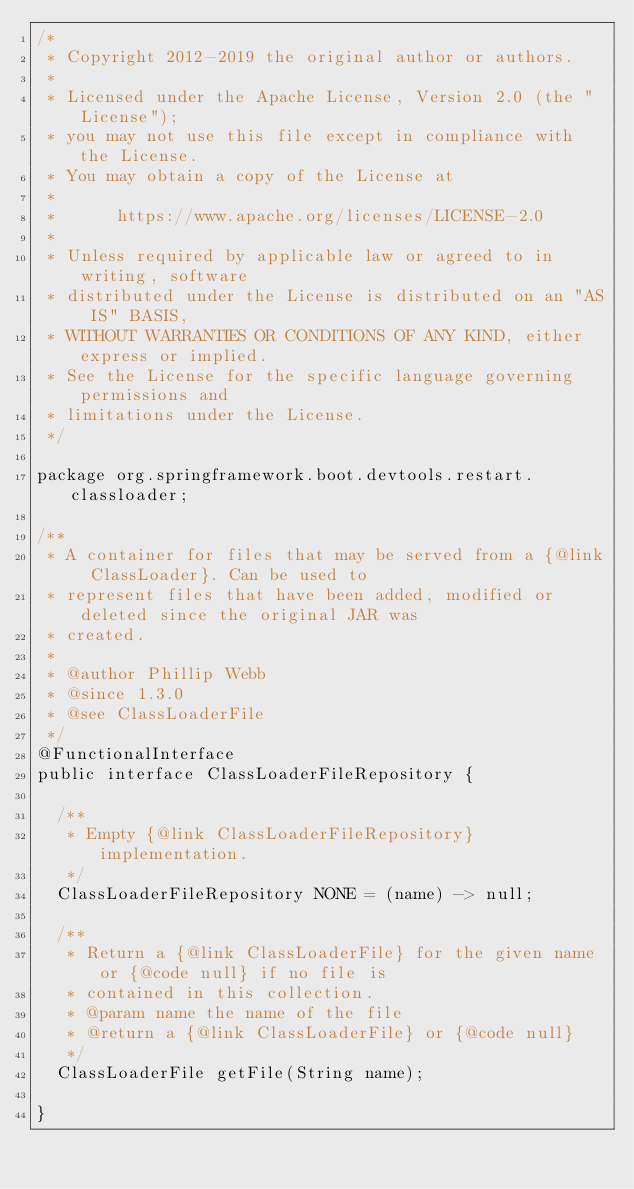Convert code to text. <code><loc_0><loc_0><loc_500><loc_500><_Java_>/*
 * Copyright 2012-2019 the original author or authors.
 *
 * Licensed under the Apache License, Version 2.0 (the "License");
 * you may not use this file except in compliance with the License.
 * You may obtain a copy of the License at
 *
 *      https://www.apache.org/licenses/LICENSE-2.0
 *
 * Unless required by applicable law or agreed to in writing, software
 * distributed under the License is distributed on an "AS IS" BASIS,
 * WITHOUT WARRANTIES OR CONDITIONS OF ANY KIND, either express or implied.
 * See the License for the specific language governing permissions and
 * limitations under the License.
 */

package org.springframework.boot.devtools.restart.classloader;

/**
 * A container for files that may be served from a {@link ClassLoader}. Can be used to
 * represent files that have been added, modified or deleted since the original JAR was
 * created.
 *
 * @author Phillip Webb
 * @since 1.3.0
 * @see ClassLoaderFile
 */
@FunctionalInterface
public interface ClassLoaderFileRepository {

	/**
	 * Empty {@link ClassLoaderFileRepository} implementation.
	 */
	ClassLoaderFileRepository NONE = (name) -> null;

	/**
	 * Return a {@link ClassLoaderFile} for the given name or {@code null} if no file is
	 * contained in this collection.
	 * @param name the name of the file
	 * @return a {@link ClassLoaderFile} or {@code null}
	 */
	ClassLoaderFile getFile(String name);

}
</code> 